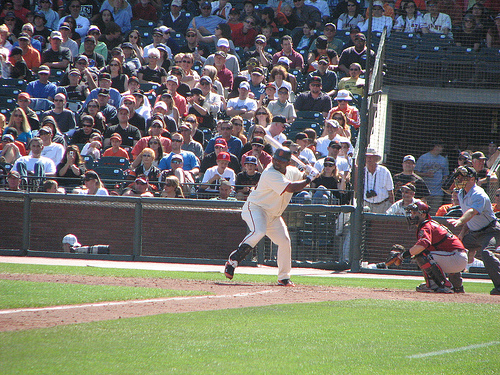What is the role of the person in the protective gear? The individual in protective gear is the catcher. They are tasked with catching pitches that are not hit by the batter and protecting home plate. Can you describe their stance or position? Certainly, the catcher is squatting behind home plate, wearing a helmet, a face mask, chest protector, and leg guards, all of which are part of their equipment to ensure safety during the game. 